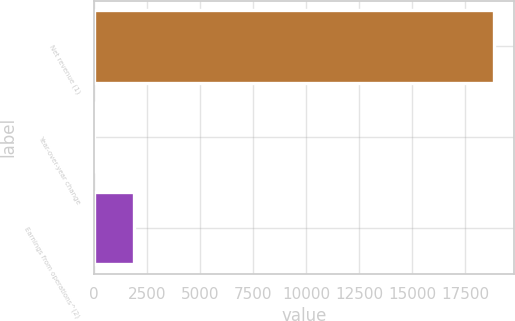<chart> <loc_0><loc_0><loc_500><loc_500><bar_chart><fcel>Net revenue (1)<fcel>Year-over-year change<fcel>Earnings from operations^(2)<nl><fcel>18872<fcel>4.7<fcel>1891.43<nl></chart> 